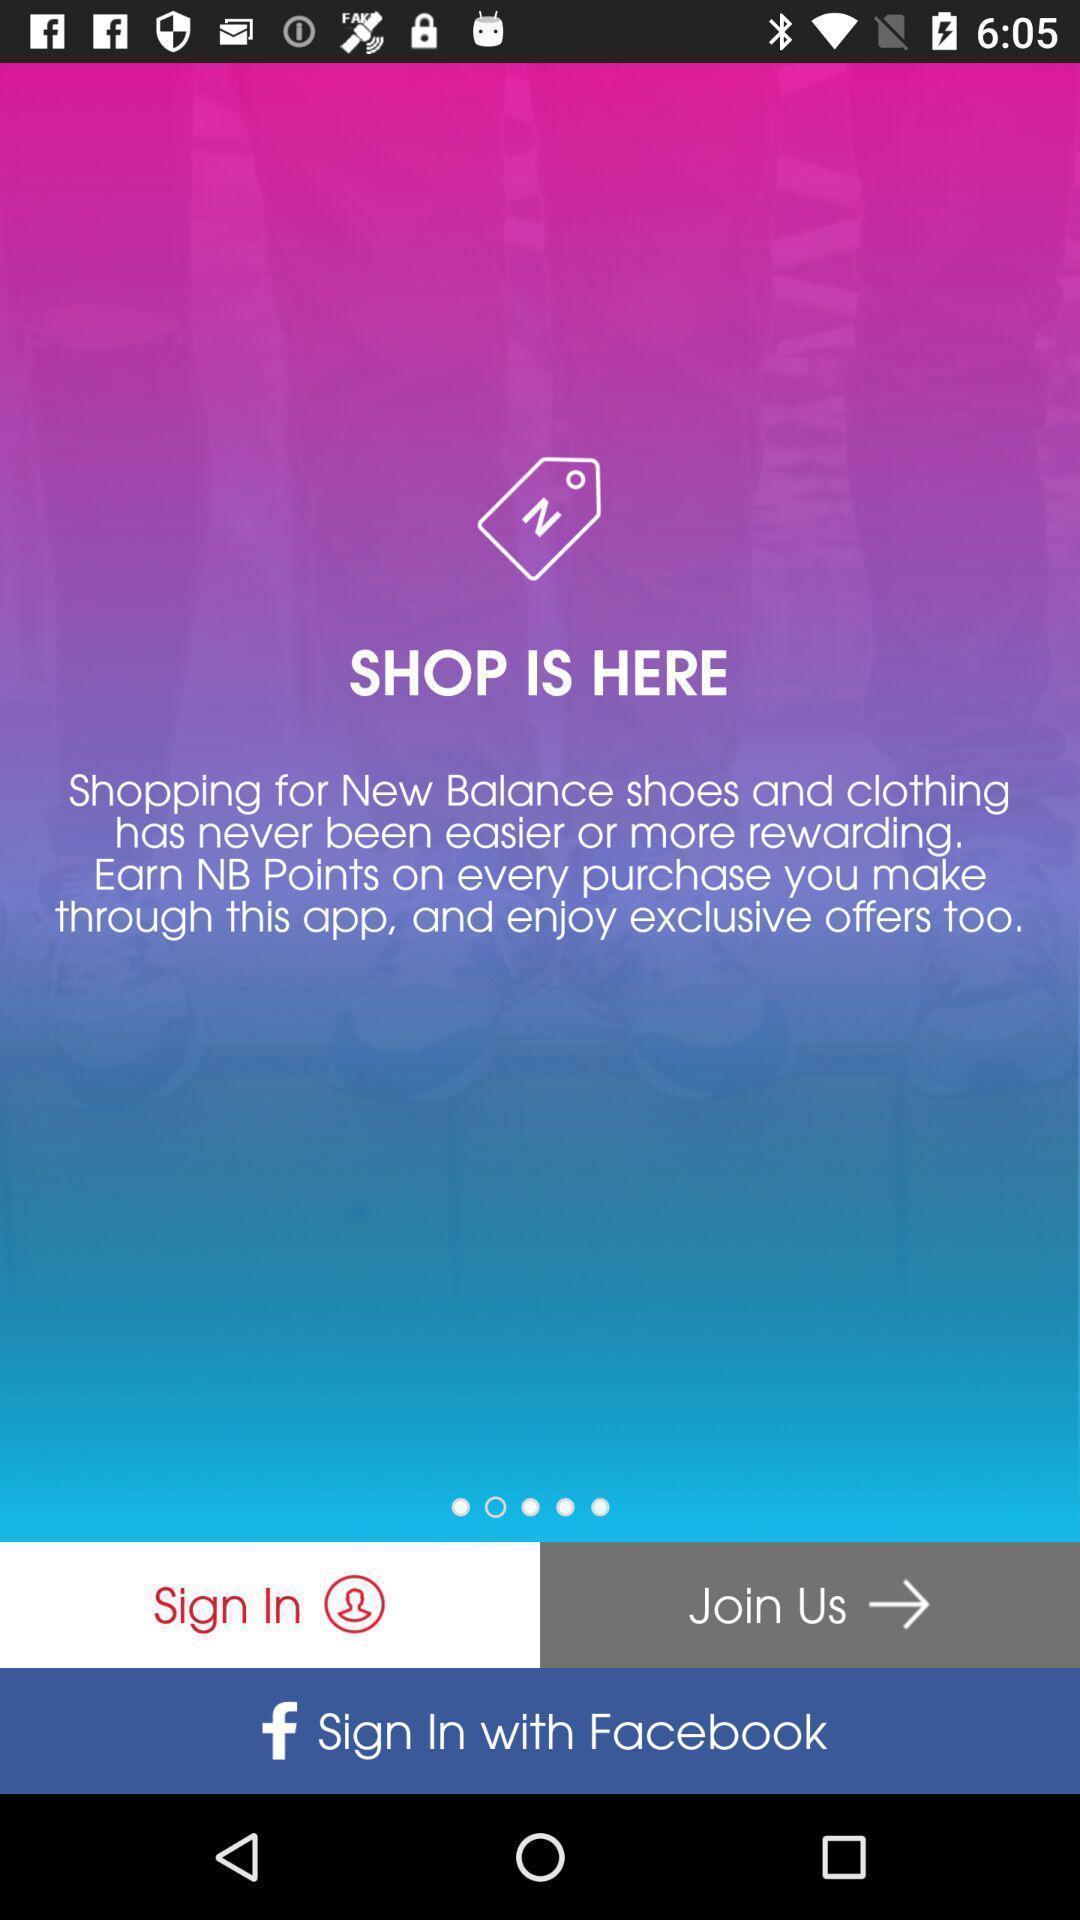Give me a narrative description of this picture. Sign in page. 